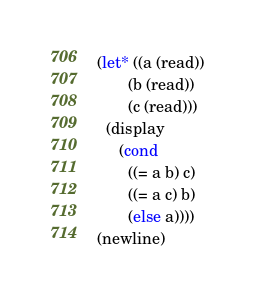<code> <loc_0><loc_0><loc_500><loc_500><_Scheme_>
(let* ((a (read))
       (b (read))
       (c (read)))
  (display
     (cond 
       ((= a b) c)
       ((= a c) b)
       (else a))))
(newline)
</code> 